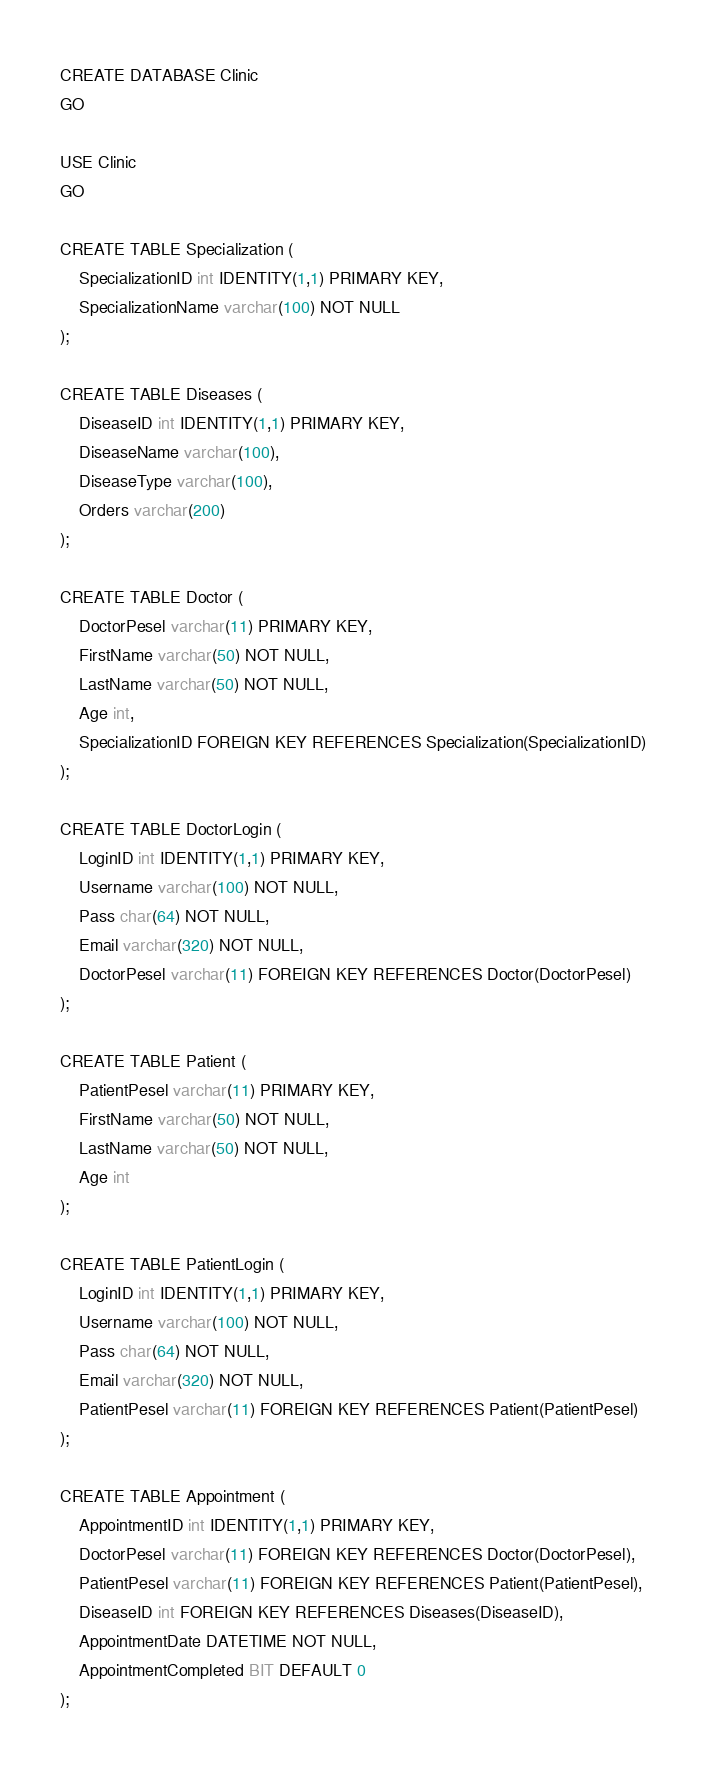<code> <loc_0><loc_0><loc_500><loc_500><_SQL_>CREATE DATABASE Clinic
GO

USE Clinic
GO

CREATE TABLE Specialization (
	SpecializationID int IDENTITY(1,1) PRIMARY KEY,
	SpecializationName varchar(100) NOT NULL
);

CREATE TABLE Diseases (
	DiseaseID int IDENTITY(1,1) PRIMARY KEY,
	DiseaseName varchar(100),
	DiseaseType varchar(100),
	Orders varchar(200)
);

CREATE TABLE Doctor (
	DoctorPesel varchar(11) PRIMARY KEY,
	FirstName varchar(50) NOT NULL,
	LastName varchar(50) NOT NULL,
	Age int,
	SpecializationID FOREIGN KEY REFERENCES Specialization(SpecializationID)
);

CREATE TABLE DoctorLogin (
	LoginID int IDENTITY(1,1) PRIMARY KEY,
	Username varchar(100) NOT NULL,
	Pass char(64) NOT NULL,
	Email varchar(320) NOT NULL,
	DoctorPesel varchar(11) FOREIGN KEY REFERENCES Doctor(DoctorPesel)
);

CREATE TABLE Patient (
	PatientPesel varchar(11) PRIMARY KEY,
	FirstName varchar(50) NOT NULL,
	LastName varchar(50) NOT NULL,
	Age int
);

CREATE TABLE PatientLogin (
	LoginID int IDENTITY(1,1) PRIMARY KEY,
	Username varchar(100) NOT NULL,
	Pass char(64) NOT NULL,
	Email varchar(320) NOT NULL,
	PatientPesel varchar(11) FOREIGN KEY REFERENCES Patient(PatientPesel)
);	 

CREATE TABLE Appointment (
	AppointmentID int IDENTITY(1,1) PRIMARY KEY,
	DoctorPesel varchar(11) FOREIGN KEY REFERENCES Doctor(DoctorPesel),
	PatientPesel varchar(11) FOREIGN KEY REFERENCES Patient(PatientPesel),
	DiseaseID int FOREIGN KEY REFERENCES Diseases(DiseaseID),
	AppointmentDate DATETIME NOT NULL,
	AppointmentCompleted BIT DEFAULT 0
);
</code> 